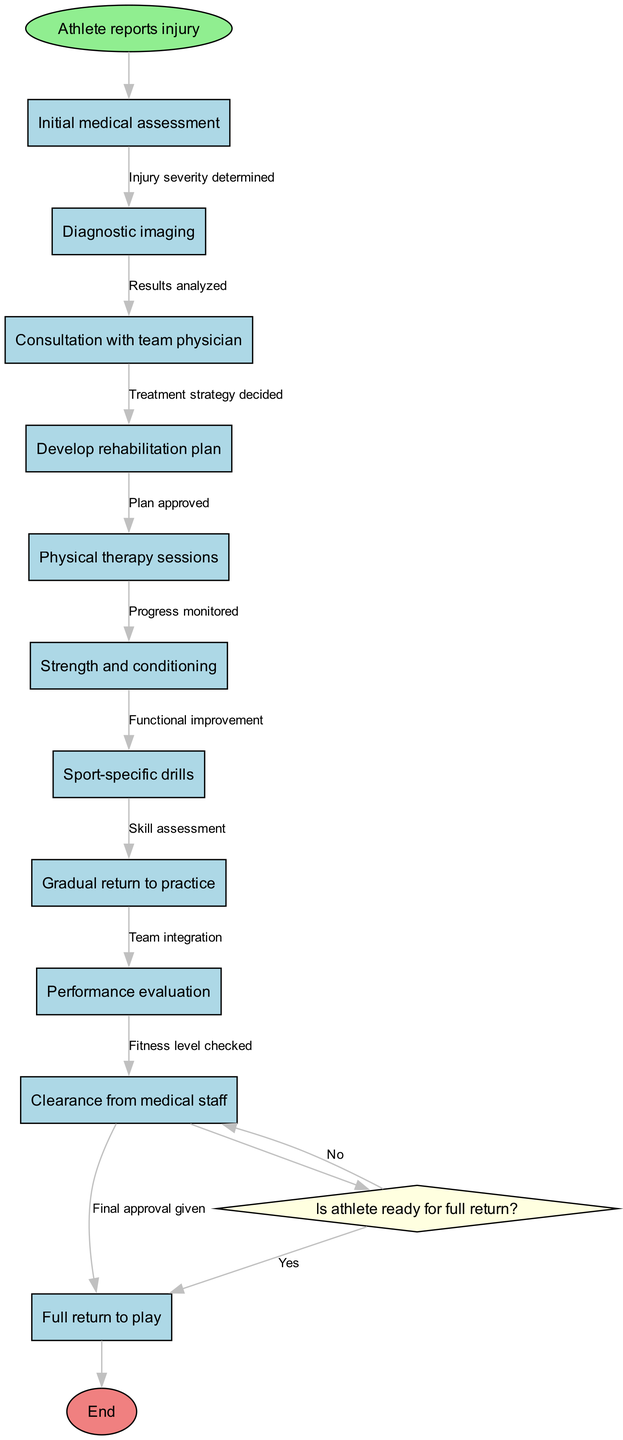What is the first step in the rehabilitation protocol? The diagram indicates that the process starts with the athlete reporting the injury, marking the beginning of the rehabilitation protocol.
Answer: Athlete reports injury How many nodes are present in the diagram? The diagram contains a total of 11 nodes: 1 start node, 10 rehabilitation steps, and 1 end node, summing up to 11 distinct points in the flowchart.
Answer: 11 Which step follows the physical therapy sessions? According to the flow of the rehabilitation protocol, the next step after physical therapy sessions is strength and conditioning, indicating the progression in the rehabilitation.
Answer: Strength and conditioning What is the condition assessed before making the final return decision? The decision node checks if the athlete is ready for full return, focusing specifically on the athlete's readiness as the main condition that influences the outcome of the rehabilitation process.
Answer: Is athlete ready for full return? If the athlete is not ready for a full return, what step do they take? If the answer to the decision of readiness is 'no', the protocol specifies to continue rehabilitation, indicating that further efforts are needed before a full return can be considered.
Answer: Continue rehabilitation What happens after the performance evaluation? After the performance evaluation, the next action is to check the fitness level, which is essential before the athlete can be cleared for full return to play.
Answer: Fitness level checked How many edges are between nodes in the protocol? There are 10 edges depicted in the diagram, connecting the 11 nodes, with each edge representing a transition or relationship between the steps in the rehabilitation process.
Answer: 10 What type of node follows the strength and conditioning step? The flowchart shows that after the strength and conditioning step, the next node represents sport-specific drills, illustrating the tailored approach towards the athlete's rehabilitation.
Answer: Sport-specific drills What is the final step before the full return to play? The step right before the full return to play is the clearance from medical staff, indicating that a medical examination is required to ensure the athlete is fit for competition.
Answer: Clearance from medical staff 